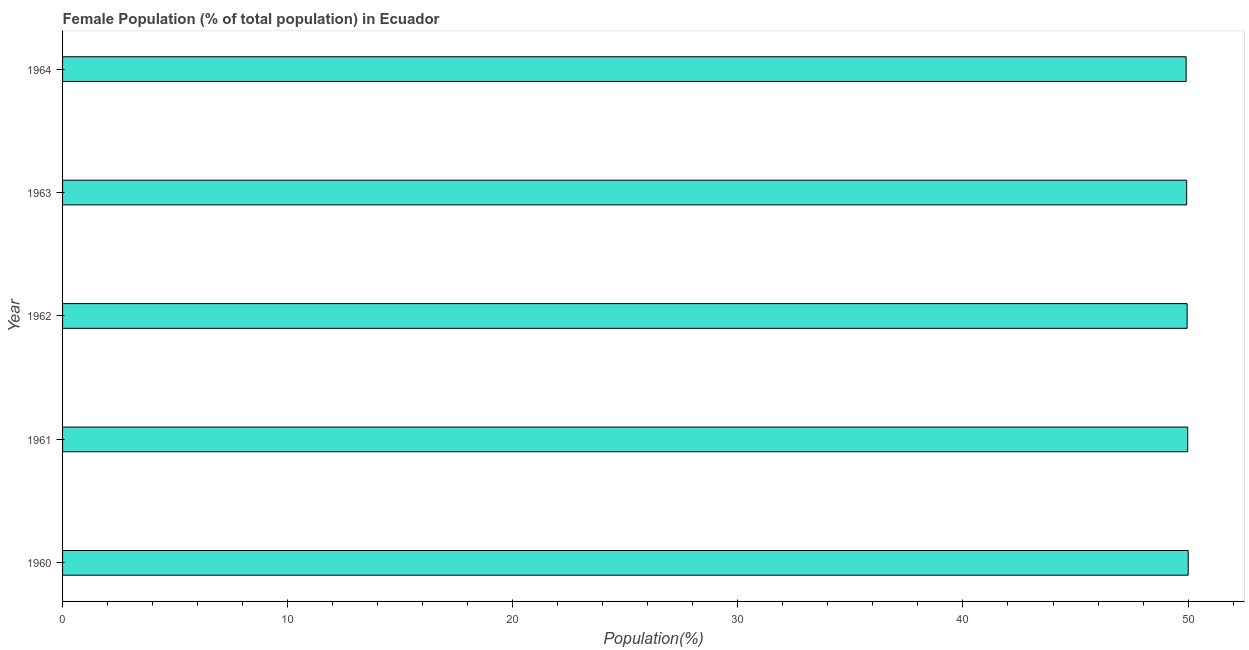Does the graph contain any zero values?
Offer a terse response. No. Does the graph contain grids?
Give a very brief answer. No. What is the title of the graph?
Provide a succinct answer. Female Population (% of total population) in Ecuador. What is the label or title of the X-axis?
Your answer should be compact. Population(%). What is the label or title of the Y-axis?
Provide a succinct answer. Year. What is the female population in 1960?
Provide a short and direct response. 50.01. Across all years, what is the maximum female population?
Provide a short and direct response. 50.01. Across all years, what is the minimum female population?
Ensure brevity in your answer.  49.91. In which year was the female population minimum?
Your answer should be very brief. 1964. What is the sum of the female population?
Offer a terse response. 249.8. What is the difference between the female population in 1961 and 1962?
Your response must be concise. 0.02. What is the average female population per year?
Offer a terse response. 49.96. What is the median female population?
Provide a succinct answer. 49.96. Do a majority of the years between 1964 and 1960 (inclusive) have female population greater than 2 %?
Offer a terse response. Yes. What is the ratio of the female population in 1960 to that in 1963?
Offer a very short reply. 1. What is the difference between the highest and the second highest female population?
Your answer should be compact. 0.02. Is the sum of the female population in 1962 and 1963 greater than the maximum female population across all years?
Offer a very short reply. Yes. What is the difference between the highest and the lowest female population?
Ensure brevity in your answer.  0.09. How many bars are there?
Give a very brief answer. 5. Are the values on the major ticks of X-axis written in scientific E-notation?
Your answer should be compact. No. What is the Population(%) in 1960?
Offer a very short reply. 50.01. What is the Population(%) in 1961?
Ensure brevity in your answer.  49.98. What is the Population(%) in 1962?
Provide a short and direct response. 49.96. What is the Population(%) of 1963?
Provide a short and direct response. 49.94. What is the Population(%) of 1964?
Keep it short and to the point. 49.91. What is the difference between the Population(%) in 1960 and 1961?
Your answer should be compact. 0.02. What is the difference between the Population(%) in 1960 and 1962?
Keep it short and to the point. 0.05. What is the difference between the Population(%) in 1960 and 1963?
Your response must be concise. 0.07. What is the difference between the Population(%) in 1960 and 1964?
Your answer should be compact. 0.09. What is the difference between the Population(%) in 1961 and 1962?
Your answer should be very brief. 0.02. What is the difference between the Population(%) in 1961 and 1963?
Your response must be concise. 0.05. What is the difference between the Population(%) in 1961 and 1964?
Keep it short and to the point. 0.07. What is the difference between the Population(%) in 1962 and 1963?
Ensure brevity in your answer.  0.02. What is the difference between the Population(%) in 1962 and 1964?
Make the answer very short. 0.04. What is the difference between the Population(%) in 1963 and 1964?
Ensure brevity in your answer.  0.02. What is the ratio of the Population(%) in 1960 to that in 1961?
Your answer should be very brief. 1. What is the ratio of the Population(%) in 1961 to that in 1962?
Offer a terse response. 1. What is the ratio of the Population(%) in 1961 to that in 1963?
Offer a terse response. 1. What is the ratio of the Population(%) in 1962 to that in 1963?
Provide a short and direct response. 1. What is the ratio of the Population(%) in 1962 to that in 1964?
Provide a succinct answer. 1. What is the ratio of the Population(%) in 1963 to that in 1964?
Make the answer very short. 1. 